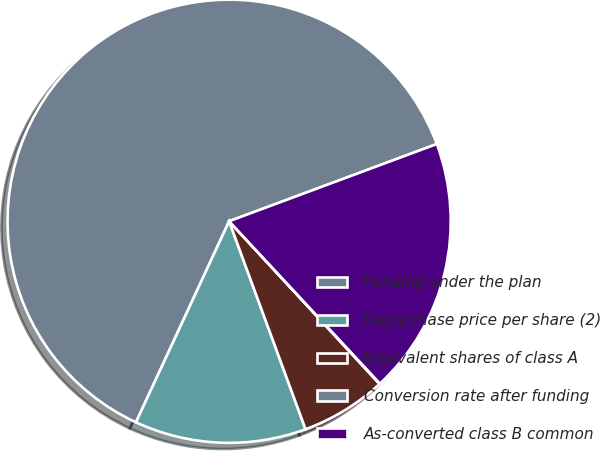<chart> <loc_0><loc_0><loc_500><loc_500><pie_chart><fcel>Funding under the plan<fcel>Repurchase price per share (2)<fcel>Equivalent shares of class A<fcel>Conversion rate after funding<fcel>As-converted class B common<nl><fcel>62.42%<fcel>12.51%<fcel>6.27%<fcel>0.04%<fcel>18.75%<nl></chart> 